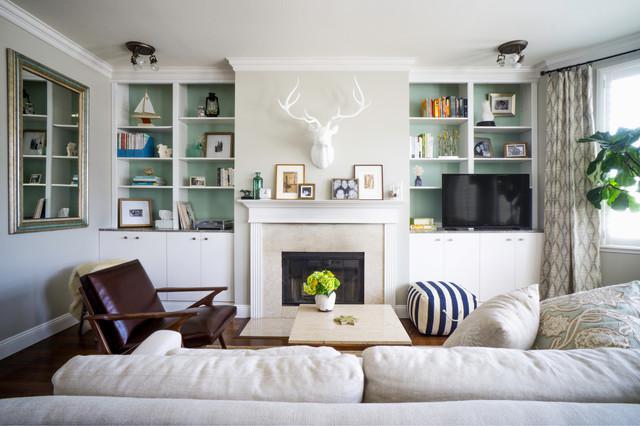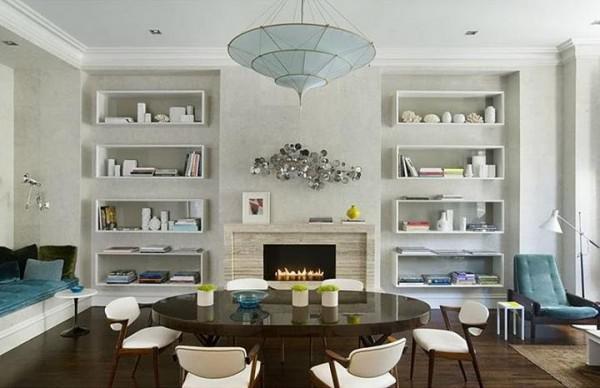The first image is the image on the left, the second image is the image on the right. Examine the images to the left and right. Is the description "In one image, white shelving units, in a room with a sofa, chair and coffee table, have four levels of upper shelves and solid panel doors below." accurate? Answer yes or no. Yes. The first image is the image on the left, the second image is the image on the right. Considering the images on both sides, is "A plant is sitting near the furniture in the room in the image on the right." valid? Answer yes or no. No. 